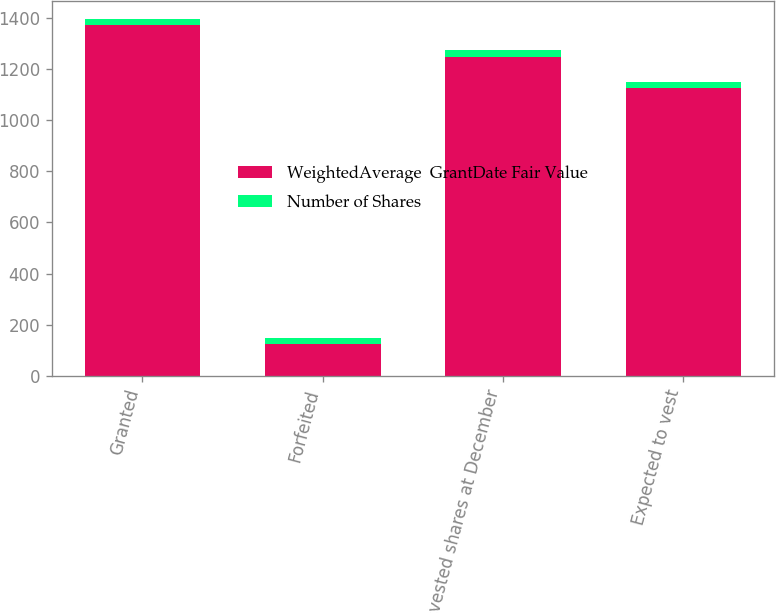Convert chart. <chart><loc_0><loc_0><loc_500><loc_500><stacked_bar_chart><ecel><fcel>Granted<fcel>Forfeited<fcel>Nonvested shares at December<fcel>Expected to vest<nl><fcel>WeightedAverage  GrantDate Fair Value<fcel>1371<fcel>123<fcel>1248<fcel>1125<nl><fcel>Number of Shares<fcel>24.69<fcel>24.67<fcel>24.69<fcel>24.69<nl></chart> 